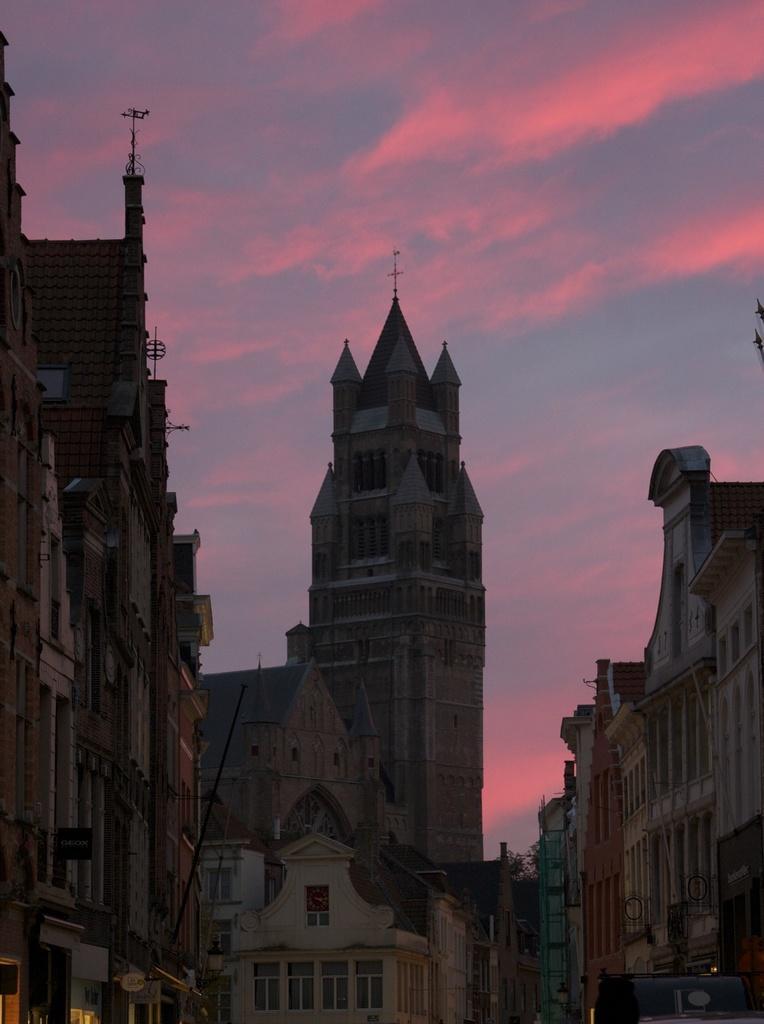Please provide a concise description of this image. In this image I can see few buildings and few metal rods on the buildings. In the background I can see few trees and the sky. 